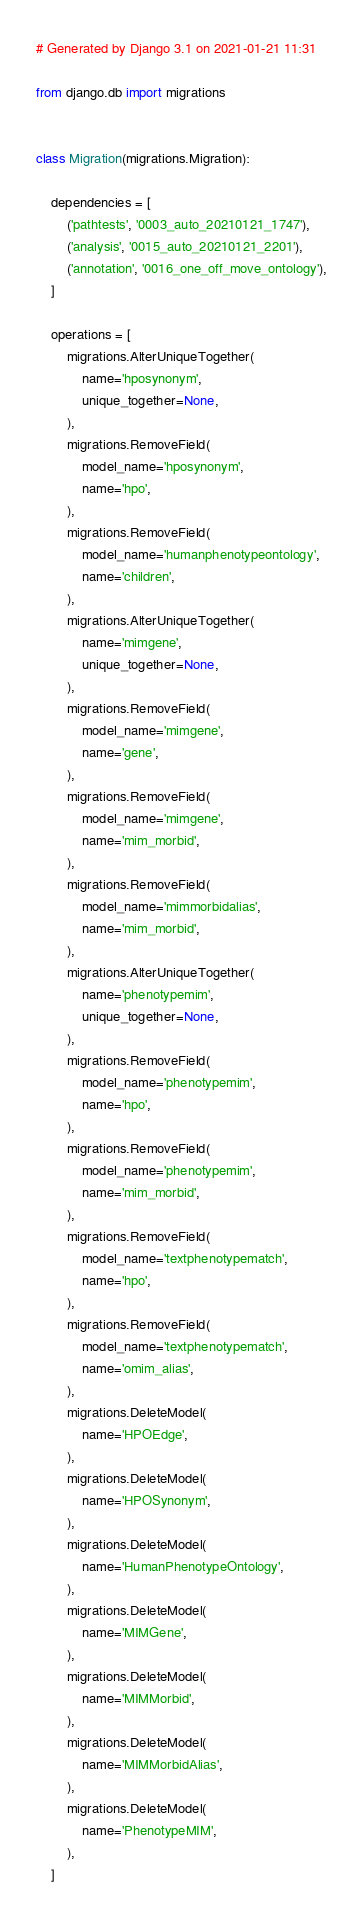<code> <loc_0><loc_0><loc_500><loc_500><_Python_># Generated by Django 3.1 on 2021-01-21 11:31

from django.db import migrations


class Migration(migrations.Migration):

    dependencies = [
        ('pathtests', '0003_auto_20210121_1747'),
        ('analysis', '0015_auto_20210121_2201'),
        ('annotation', '0016_one_off_move_ontology'),
    ]

    operations = [
        migrations.AlterUniqueTogether(
            name='hposynonym',
            unique_together=None,
        ),
        migrations.RemoveField(
            model_name='hposynonym',
            name='hpo',
        ),
        migrations.RemoveField(
            model_name='humanphenotypeontology',
            name='children',
        ),
        migrations.AlterUniqueTogether(
            name='mimgene',
            unique_together=None,
        ),
        migrations.RemoveField(
            model_name='mimgene',
            name='gene',
        ),
        migrations.RemoveField(
            model_name='mimgene',
            name='mim_morbid',
        ),
        migrations.RemoveField(
            model_name='mimmorbidalias',
            name='mim_morbid',
        ),
        migrations.AlterUniqueTogether(
            name='phenotypemim',
            unique_together=None,
        ),
        migrations.RemoveField(
            model_name='phenotypemim',
            name='hpo',
        ),
        migrations.RemoveField(
            model_name='phenotypemim',
            name='mim_morbid',
        ),
        migrations.RemoveField(
            model_name='textphenotypematch',
            name='hpo',
        ),
        migrations.RemoveField(
            model_name='textphenotypematch',
            name='omim_alias',
        ),
        migrations.DeleteModel(
            name='HPOEdge',
        ),
        migrations.DeleteModel(
            name='HPOSynonym',
        ),
        migrations.DeleteModel(
            name='HumanPhenotypeOntology',
        ),
        migrations.DeleteModel(
            name='MIMGene',
        ),
        migrations.DeleteModel(
            name='MIMMorbid',
        ),
        migrations.DeleteModel(
            name='MIMMorbidAlias',
        ),
        migrations.DeleteModel(
            name='PhenotypeMIM',
        ),
    ]
</code> 